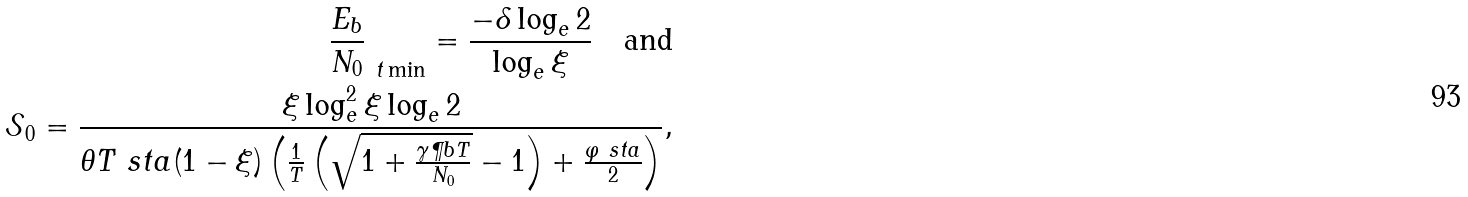<formula> <loc_0><loc_0><loc_500><loc_500>\frac { E _ { b } } { N _ { 0 } } _ { \ t \min } = \frac { - \delta \log _ { e } 2 } { \log _ { e } \xi } \quad \text {and} \\ \mathcal { S } _ { 0 } = \frac { \xi \log _ { e } ^ { 2 } \xi \log _ { e } 2 } { \theta T \ s t a ( 1 - \xi ) \left ( \frac { 1 } { T } \left ( \sqrt { 1 + \frac { \gamma \P b T } { N _ { 0 } } } - 1 \right ) + \frac { \varphi \ s t a } { 2 } \right ) } ,</formula> 